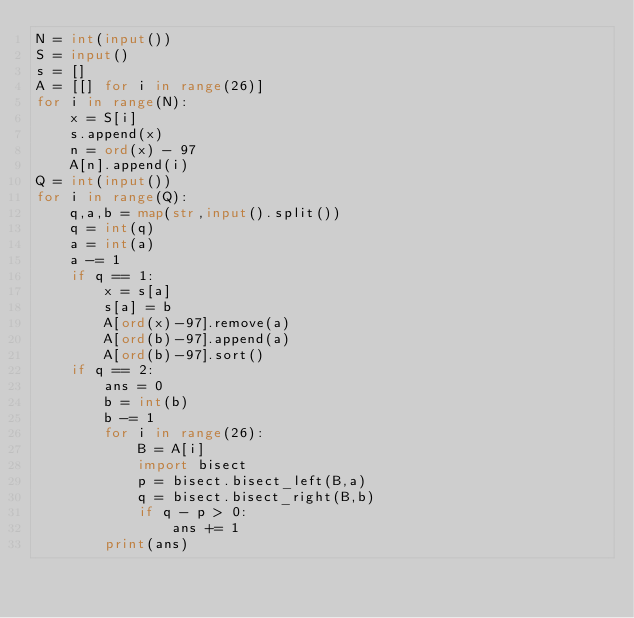Convert code to text. <code><loc_0><loc_0><loc_500><loc_500><_Python_>N = int(input())
S = input()
s = []
A = [[] for i in range(26)]
for i in range(N):
    x = S[i]
    s.append(x)
    n = ord(x) - 97
    A[n].append(i)
Q = int(input())
for i in range(Q):
    q,a,b = map(str,input().split())
    q = int(q)
    a = int(a)
    a -= 1
    if q == 1:
        x = s[a]
        s[a] = b
        A[ord(x)-97].remove(a)
        A[ord(b)-97].append(a)
        A[ord(b)-97].sort()
    if q == 2:
        ans = 0
        b = int(b)
        b -= 1
        for i in range(26):
            B = A[i]
            import bisect
            p = bisect.bisect_left(B,a)
            q = bisect.bisect_right(B,b)
            if q - p > 0:
                ans += 1
        print(ans)</code> 